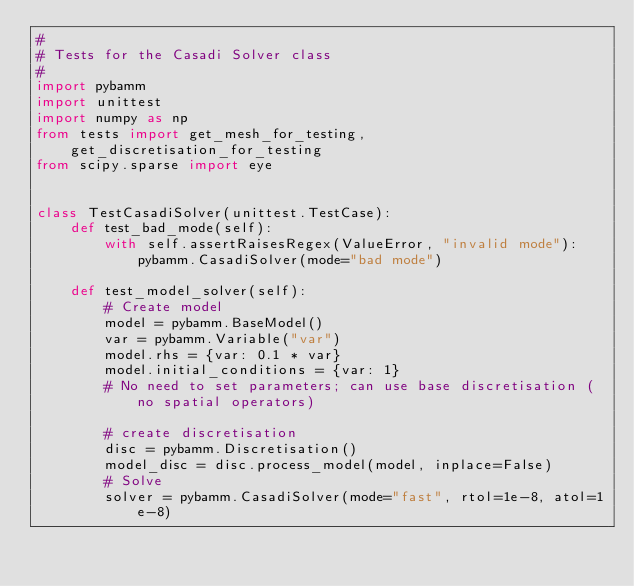<code> <loc_0><loc_0><loc_500><loc_500><_Python_>#
# Tests for the Casadi Solver class
#
import pybamm
import unittest
import numpy as np
from tests import get_mesh_for_testing, get_discretisation_for_testing
from scipy.sparse import eye


class TestCasadiSolver(unittest.TestCase):
    def test_bad_mode(self):
        with self.assertRaisesRegex(ValueError, "invalid mode"):
            pybamm.CasadiSolver(mode="bad mode")

    def test_model_solver(self):
        # Create model
        model = pybamm.BaseModel()
        var = pybamm.Variable("var")
        model.rhs = {var: 0.1 * var}
        model.initial_conditions = {var: 1}
        # No need to set parameters; can use base discretisation (no spatial operators)

        # create discretisation
        disc = pybamm.Discretisation()
        model_disc = disc.process_model(model, inplace=False)
        # Solve
        solver = pybamm.CasadiSolver(mode="fast", rtol=1e-8, atol=1e-8)</code> 